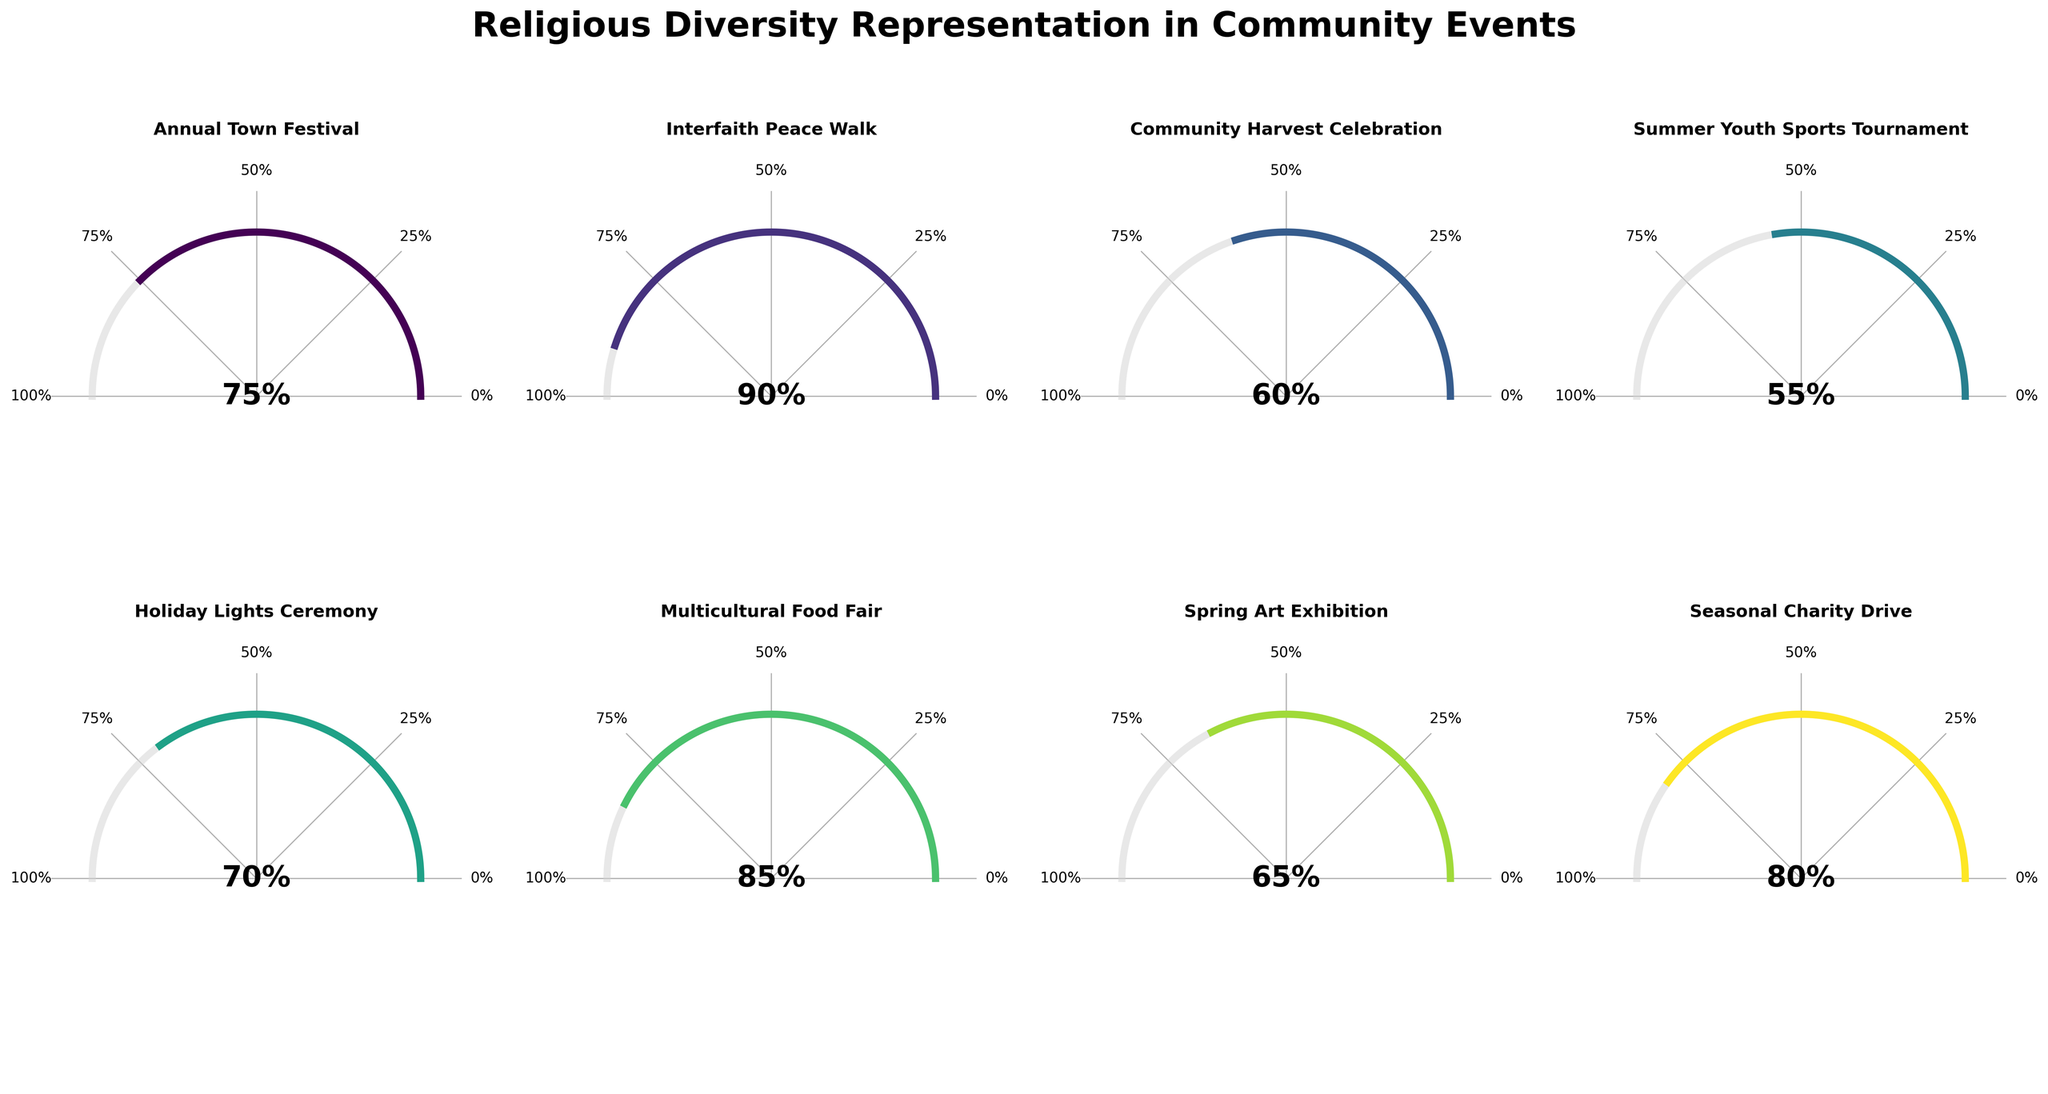What's the highest representation percentage among the community events? By looking at the gauge charts, the highest representation percentage can be identified by viewing the largest filled portion in relation to the 100% mark. The highest percentage is on the Interfaith Peace Walk gauge chart.
Answer: 90% What is the average representation percentage across all the community events? To find the average, sum all the representation percentages and divide by the number of events. (75 + 90 + 60 + 55 + 70 + 85 + 65 + 80) / 8 = 580 / 8 = 72.5
Answer: 72.5% Which event has the lowest representation percentage? By comparing all the gauge charts, the event with the least filled portion relative to the 100% mark is the Summer Youth Sports Tournament.
Answer: Summer Youth Sports Tournament How many events have a representation percentage above 70%? Count the gauge charts where the filled portion exceeds 70%. The qualifying events are Annual Town Festival (75%), Interfaith Peace Walk (90%), Multicultural Food Fair (85%), and Seasonal Charity Drive (80%).
Answer: 4 What's the difference in representation percentage between the Holiday Lights Ceremony and the Spring Art Exhibition? Subtract the representation percentage of the Spring Art Exhibition from that of the Holiday Lights Ceremony. 70% - 65% = 5%
Answer: 5% What is the second highest representation percentage among the community events? By identifying and ranking the filled portions in descending order, the second highest after Interfaith Peace Walk (90%) is the Multicultural Food Fair at 85%.
Answer: 85% If the Community Harvest Celebration improved its representation by 20%, what would be its new percentage? Add 20% to the Community Harvest Celebration's current percentage. 60% + 20% = 80%
Answer: 80% Which event is the closest to the median representation percentage? List the percentages in order (55, 60, 65, 70, 75, 80, 85, 90) and find the middle value(s). The middle values are 70 and 75. The median is the average of these two: (70 + 75) / 2 = 72.5. The closest event to this median value is Annual Town Festival (75%).
Answer: Annual Town Festival 